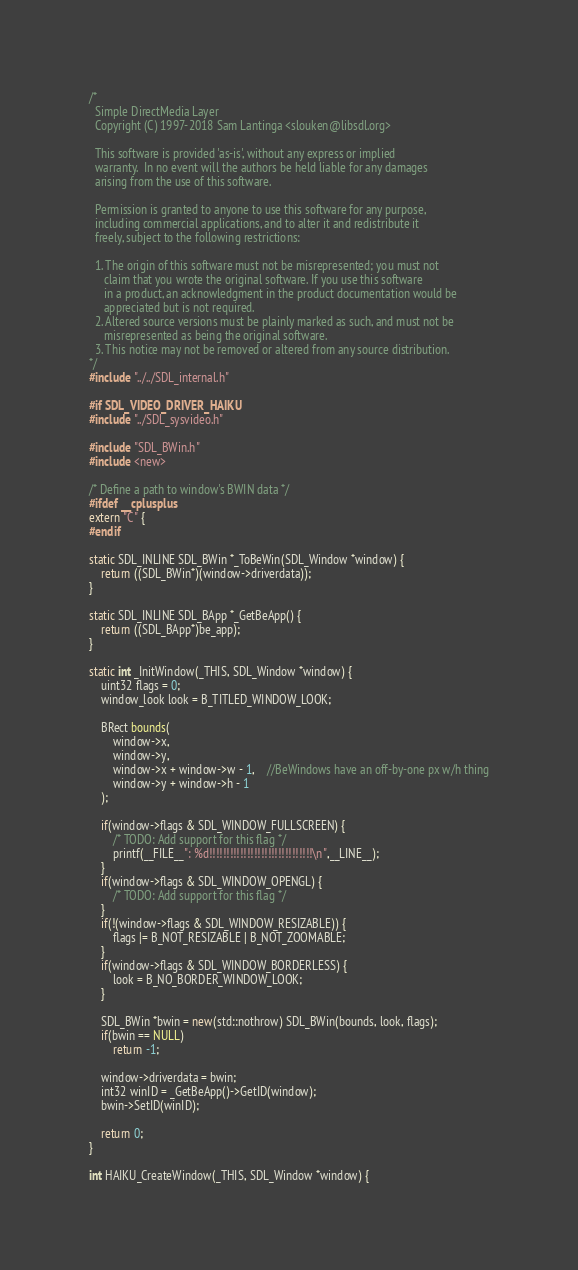<code> <loc_0><loc_0><loc_500><loc_500><_C++_>/*
  Simple DirectMedia Layer
  Copyright (C) 1997-2018 Sam Lantinga <slouken@libsdl.org>

  This software is provided 'as-is', without any express or implied
  warranty.  In no event will the authors be held liable for any damages
  arising from the use of this software.

  Permission is granted to anyone to use this software for any purpose,
  including commercial applications, and to alter it and redistribute it
  freely, subject to the following restrictions:

  1. The origin of this software must not be misrepresented; you must not
     claim that you wrote the original software. If you use this software
     in a product, an acknowledgment in the product documentation would be
     appreciated but is not required.
  2. Altered source versions must be plainly marked as such, and must not be
     misrepresented as being the original software.
  3. This notice may not be removed or altered from any source distribution.
*/
#include "../../SDL_internal.h"

#if SDL_VIDEO_DRIVER_HAIKU
#include "../SDL_sysvideo.h"

#include "SDL_BWin.h"
#include <new>

/* Define a path to window's BWIN data */
#ifdef __cplusplus
extern "C" {
#endif

static SDL_INLINE SDL_BWin *_ToBeWin(SDL_Window *window) {
	return ((SDL_BWin*)(window->driverdata));
}

static SDL_INLINE SDL_BApp *_GetBeApp() {
	return ((SDL_BApp*)be_app);
}

static int _InitWindow(_THIS, SDL_Window *window) {
	uint32 flags = 0;
	window_look look = B_TITLED_WINDOW_LOOK;

	BRect bounds(
        window->x,
        window->y,
        window->x + window->w - 1,	//BeWindows have an off-by-one px w/h thing
        window->y + window->h - 1
    );
    
    if(window->flags & SDL_WINDOW_FULLSCREEN) {
    	/* TODO: Add support for this flag */
    	printf(__FILE__": %d!!!!!!!!!!!!!!!!!!!!!!!!!!!!!!\n",__LINE__);
    }
    if(window->flags & SDL_WINDOW_OPENGL) {
    	/* TODO: Add support for this flag */
    }
    if(!(window->flags & SDL_WINDOW_RESIZABLE)) {
    	flags |= B_NOT_RESIZABLE | B_NOT_ZOOMABLE;
    }
    if(window->flags & SDL_WINDOW_BORDERLESS) {
    	look = B_NO_BORDER_WINDOW_LOOK;
    }

    SDL_BWin *bwin = new(std::nothrow) SDL_BWin(bounds, look, flags);
    if(bwin == NULL)
        return -1;

    window->driverdata = bwin;
    int32 winID = _GetBeApp()->GetID(window);
    bwin->SetID(winID);

    return 0;
}

int HAIKU_CreateWindow(_THIS, SDL_Window *window) {</code> 